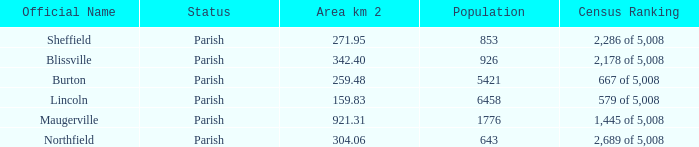What are the census ranking(s) of maugerville? 1,445 of 5,008. 